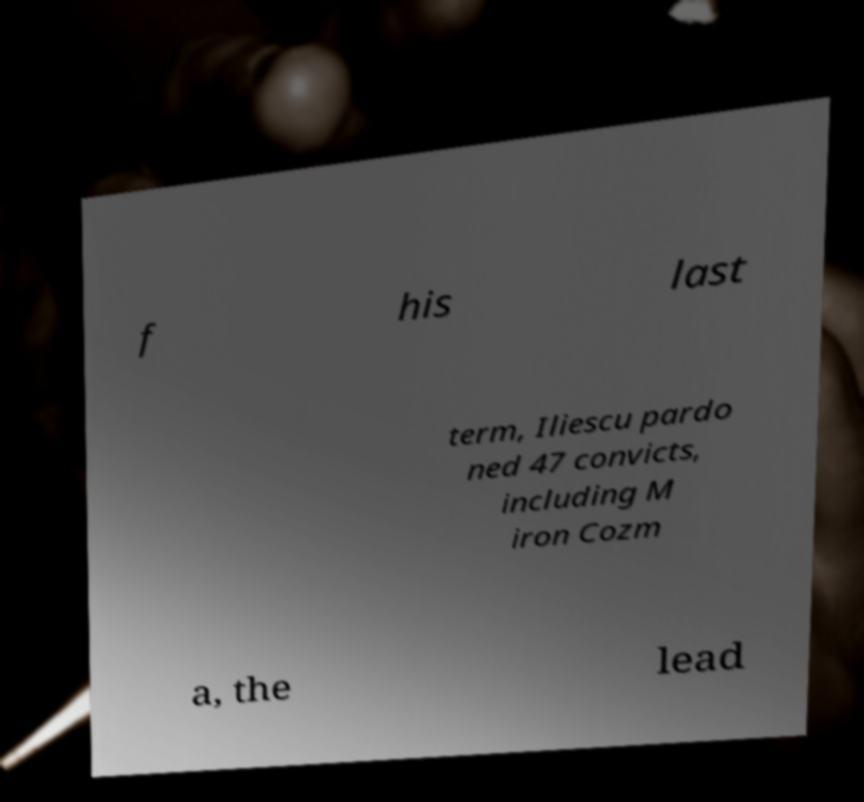Can you accurately transcribe the text from the provided image for me? f his last term, Iliescu pardo ned 47 convicts, including M iron Cozm a, the lead 